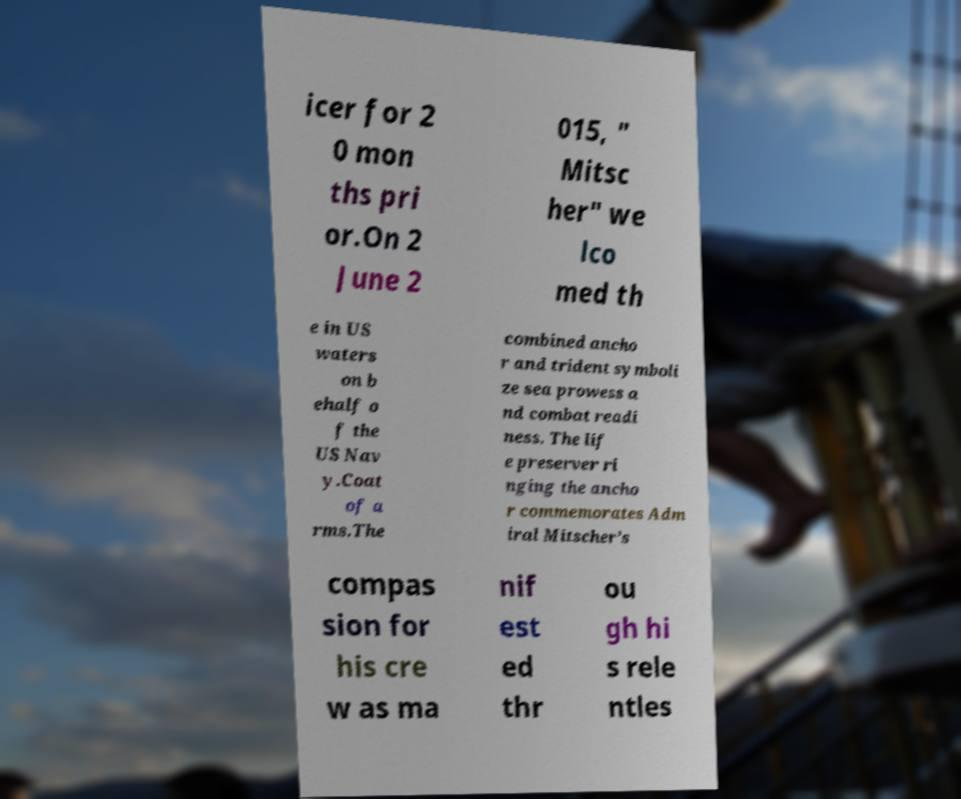Please identify and transcribe the text found in this image. icer for 2 0 mon ths pri or.On 2 June 2 015, " Mitsc her" we lco med th e in US waters on b ehalf o f the US Nav y.Coat of a rms.The combined ancho r and trident symboli ze sea prowess a nd combat readi ness. The lif e preserver ri nging the ancho r commemorates Adm iral Mitscher’s compas sion for his cre w as ma nif est ed thr ou gh hi s rele ntles 